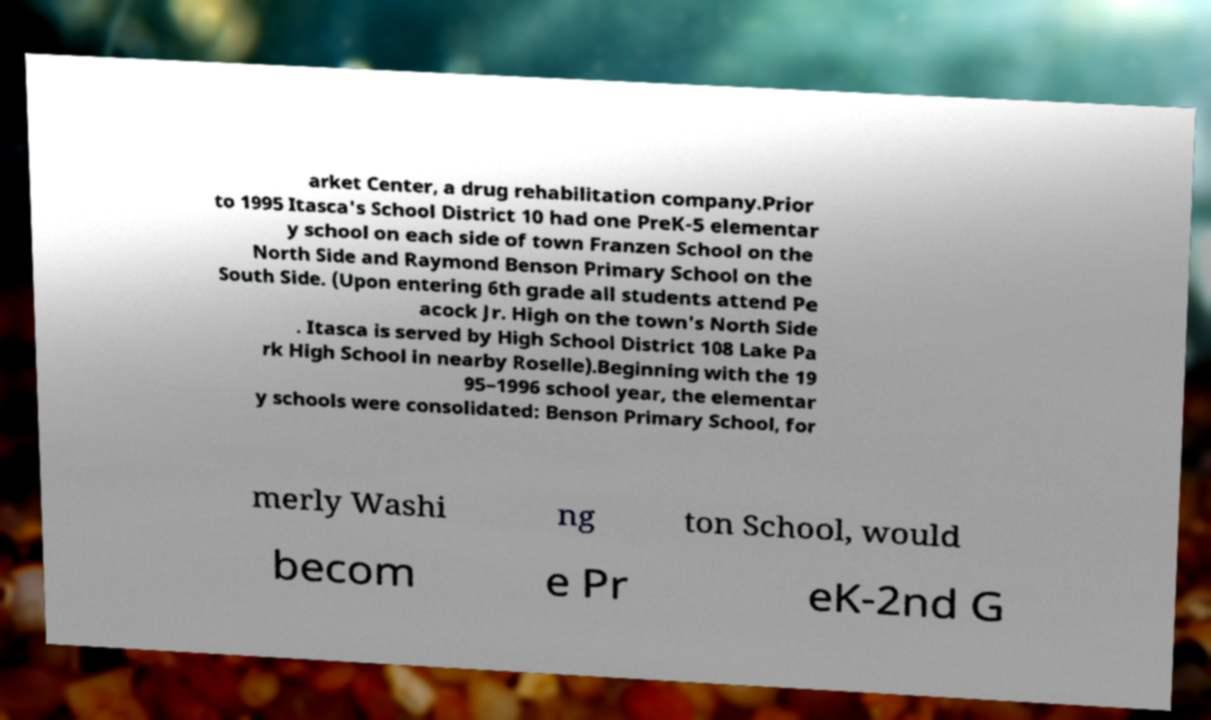There's text embedded in this image that I need extracted. Can you transcribe it verbatim? arket Center, a drug rehabilitation company.Prior to 1995 Itasca's School District 10 had one PreK-5 elementar y school on each side of town Franzen School on the North Side and Raymond Benson Primary School on the South Side. (Upon entering 6th grade all students attend Pe acock Jr. High on the town's North Side . Itasca is served by High School District 108 Lake Pa rk High School in nearby Roselle).Beginning with the 19 95–1996 school year, the elementar y schools were consolidated: Benson Primary School, for merly Washi ng ton School, would becom e Pr eK-2nd G 